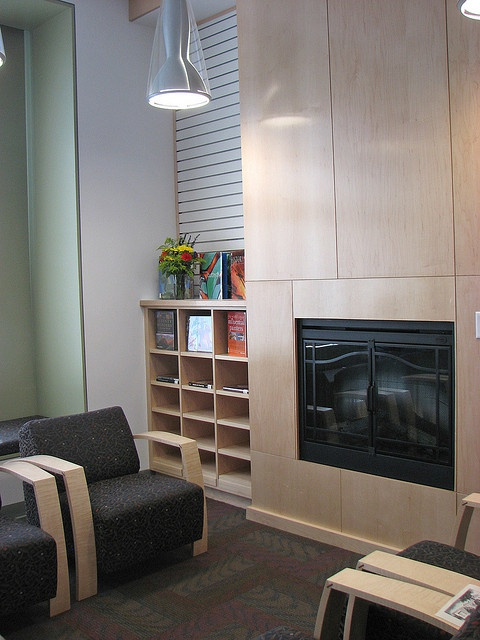Describe the objects in this image and their specific colors. I can see chair in gray, black, and maroon tones, chair in gray, black, and maroon tones, chair in gray, black, and tan tones, chair in gray, tan, and black tones, and book in gray, black, teal, and navy tones in this image. 